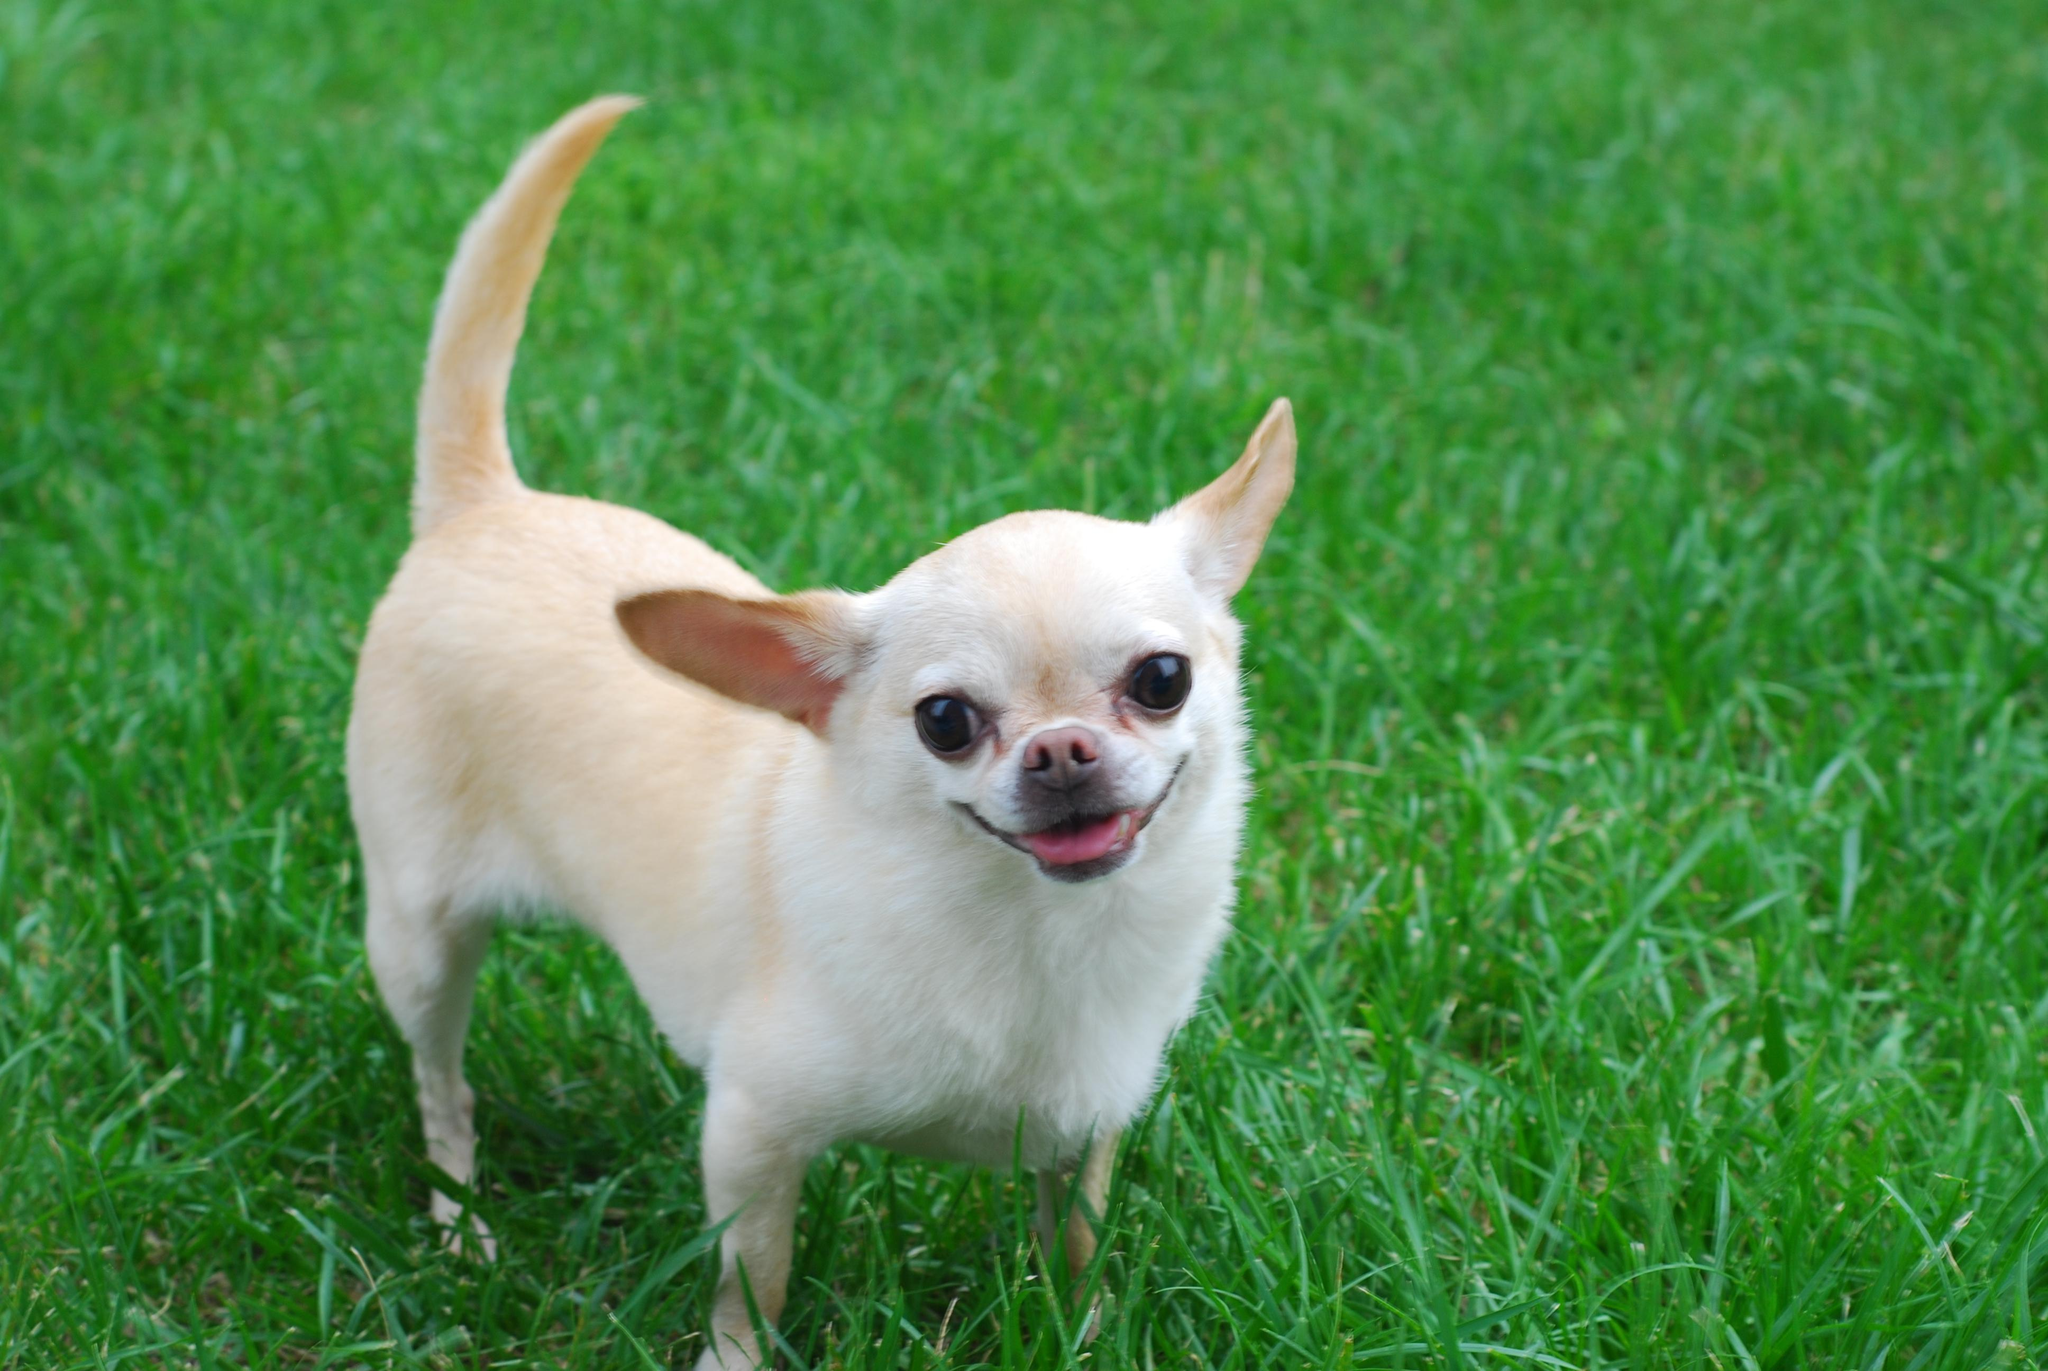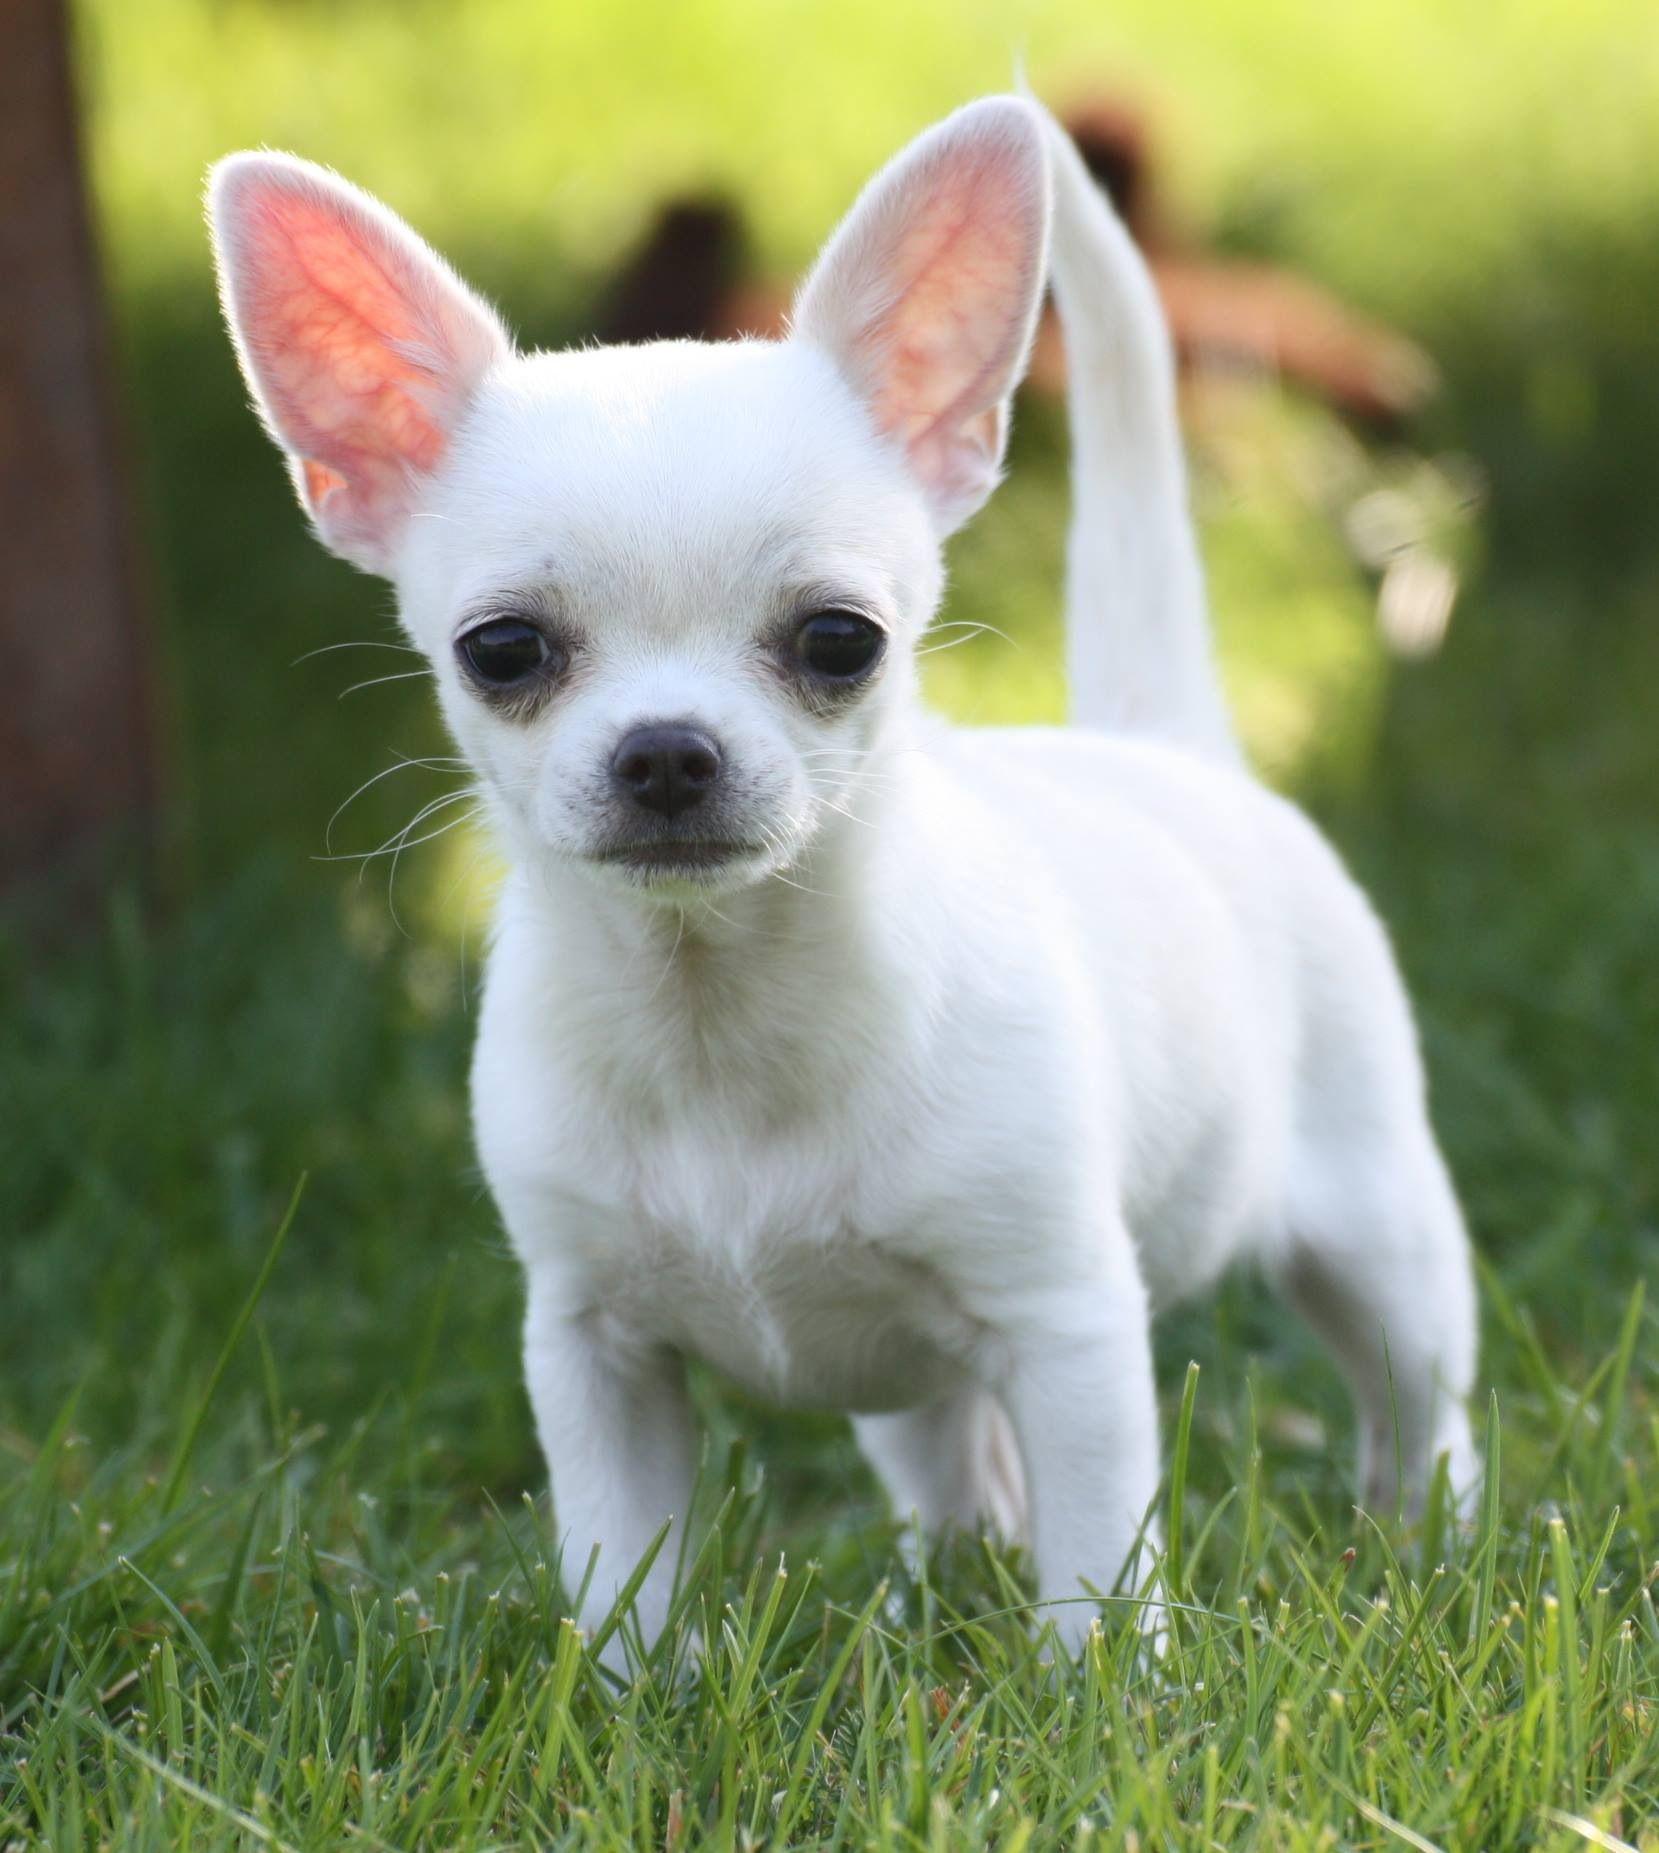The first image is the image on the left, the second image is the image on the right. Considering the images on both sides, is "All dogs are standing on grass." valid? Answer yes or no. Yes. 